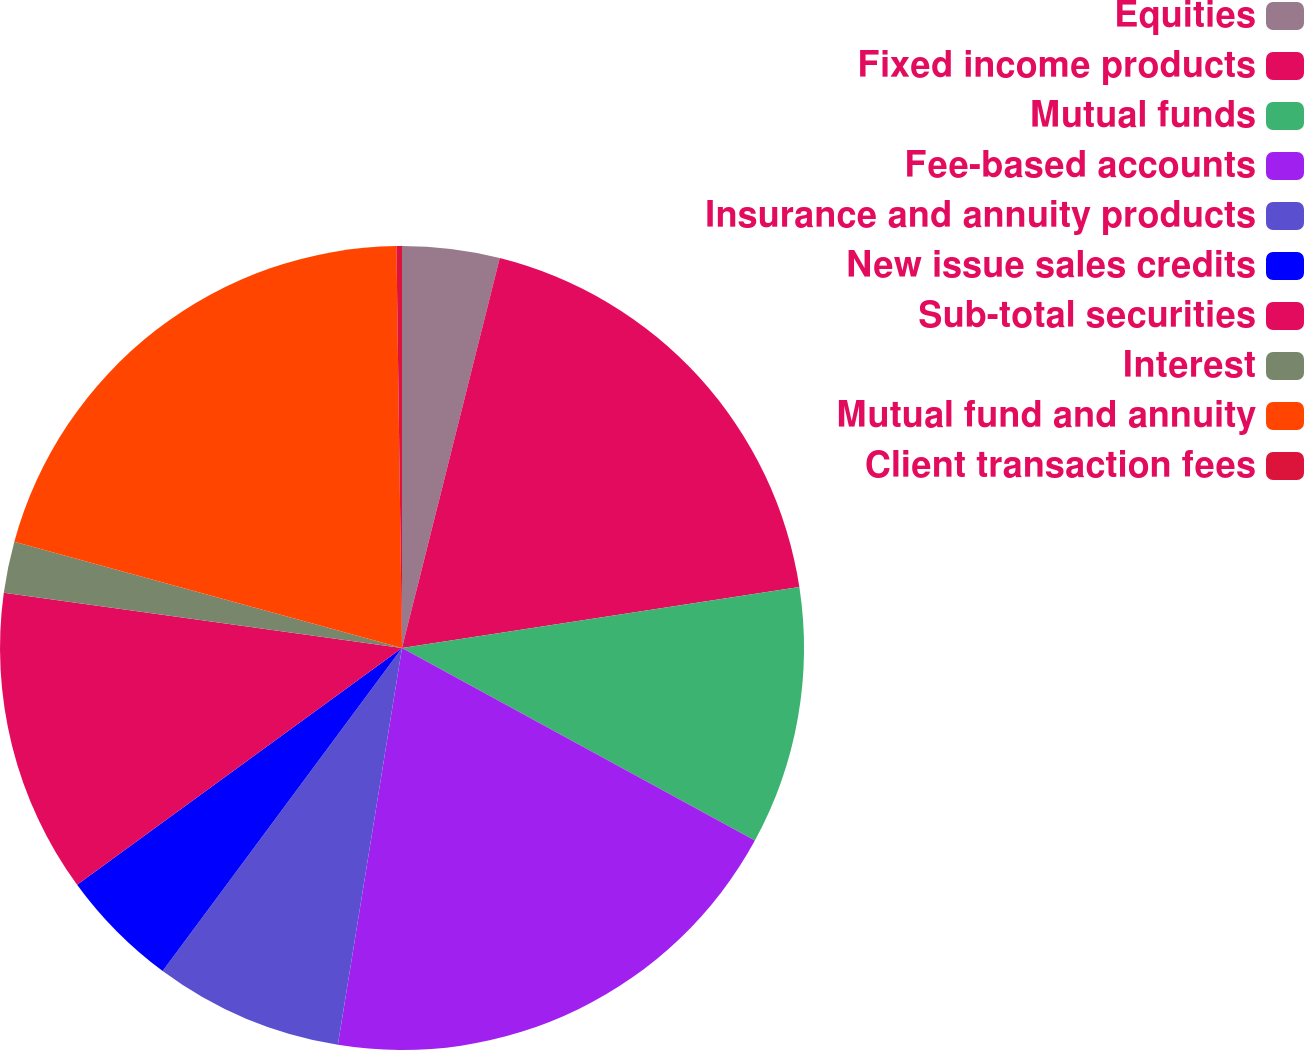<chart> <loc_0><loc_0><loc_500><loc_500><pie_chart><fcel>Equities<fcel>Fixed income products<fcel>Mutual funds<fcel>Fee-based accounts<fcel>Insurance and annuity products<fcel>New issue sales credits<fcel>Sub-total securities<fcel>Interest<fcel>Mutual fund and annuity<fcel>Client transaction fees<nl><fcel>3.91%<fcel>18.67%<fcel>10.37%<fcel>19.6%<fcel>7.6%<fcel>4.83%<fcel>12.21%<fcel>2.07%<fcel>20.52%<fcel>0.22%<nl></chart> 